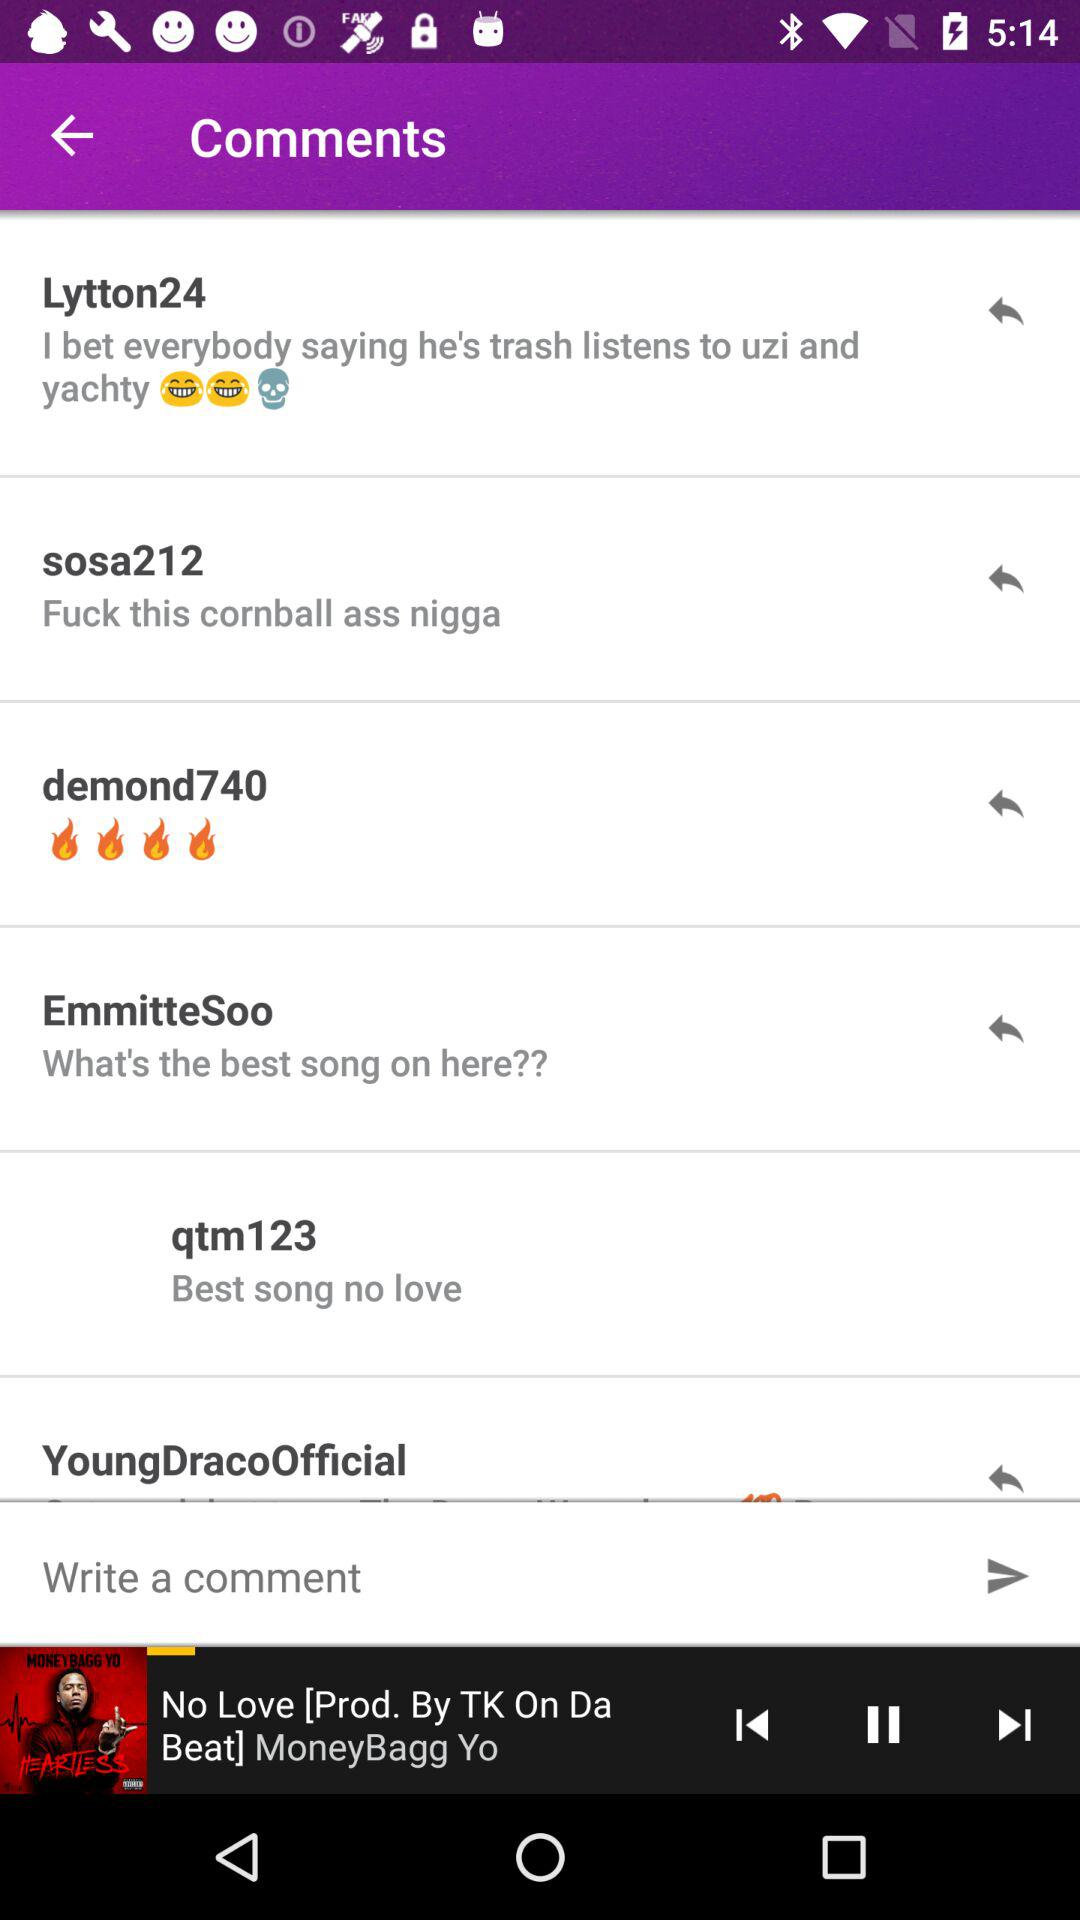Who is the singer of the song that is currently playing? The singer of the song is "MoneyBagg Yo". 